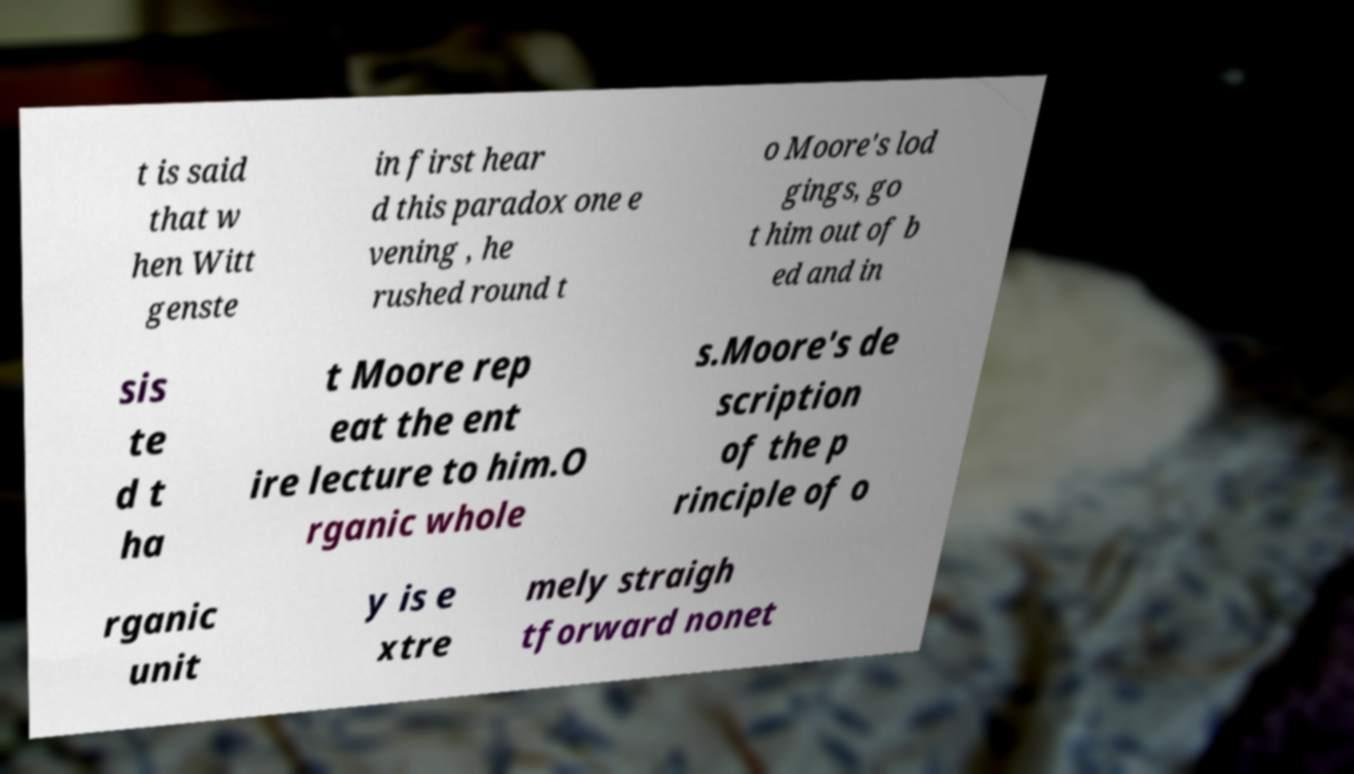For documentation purposes, I need the text within this image transcribed. Could you provide that? t is said that w hen Witt genste in first hear d this paradox one e vening , he rushed round t o Moore's lod gings, go t him out of b ed and in sis te d t ha t Moore rep eat the ent ire lecture to him.O rganic whole s.Moore's de scription of the p rinciple of o rganic unit y is e xtre mely straigh tforward nonet 